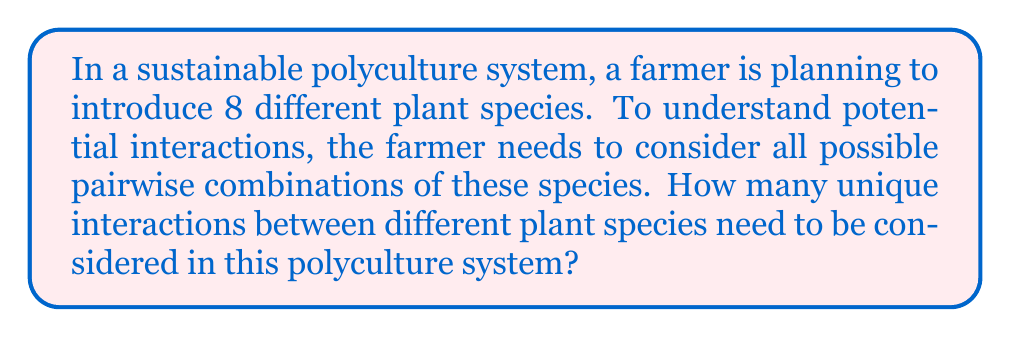Provide a solution to this math problem. To solve this problem, we need to calculate the number of unique pairs that can be formed from 8 different plant species. This is a combination problem, specifically we need to calculate $\binom{8}{2}$ or "8 choose 2".

The formula for this combination is:

$$\binom{n}{r} = \frac{n!}{r!(n-r)!}$$

Where $n$ is the total number of items (in this case, 8 plant species) and $r$ is the number of items being chosen at a time (in this case, 2 for pairwise interactions).

Let's substitute our values:

$$\binom{8}{2} = \frac{8!}{2!(8-2)!} = \frac{8!}{2!(6)!}$$

Now, let's calculate:

1) $8! = 8 \times 7 \times 6!$
2) Substituting this in our equation:
   $$\frac{8 \times 7 \times 6!}{2! \times 6!}$$
3) The $6!$ cancels out in the numerator and denominator:
   $$\frac{8 \times 7}{2 \times 1}$$
4) Multiply the numerator and denominator:
   $$\frac{56}{2}$$
5) Divide:
   $$28$$

Therefore, there are 28 unique pairwise interactions to consider in this polyculture system.
Answer: 28 